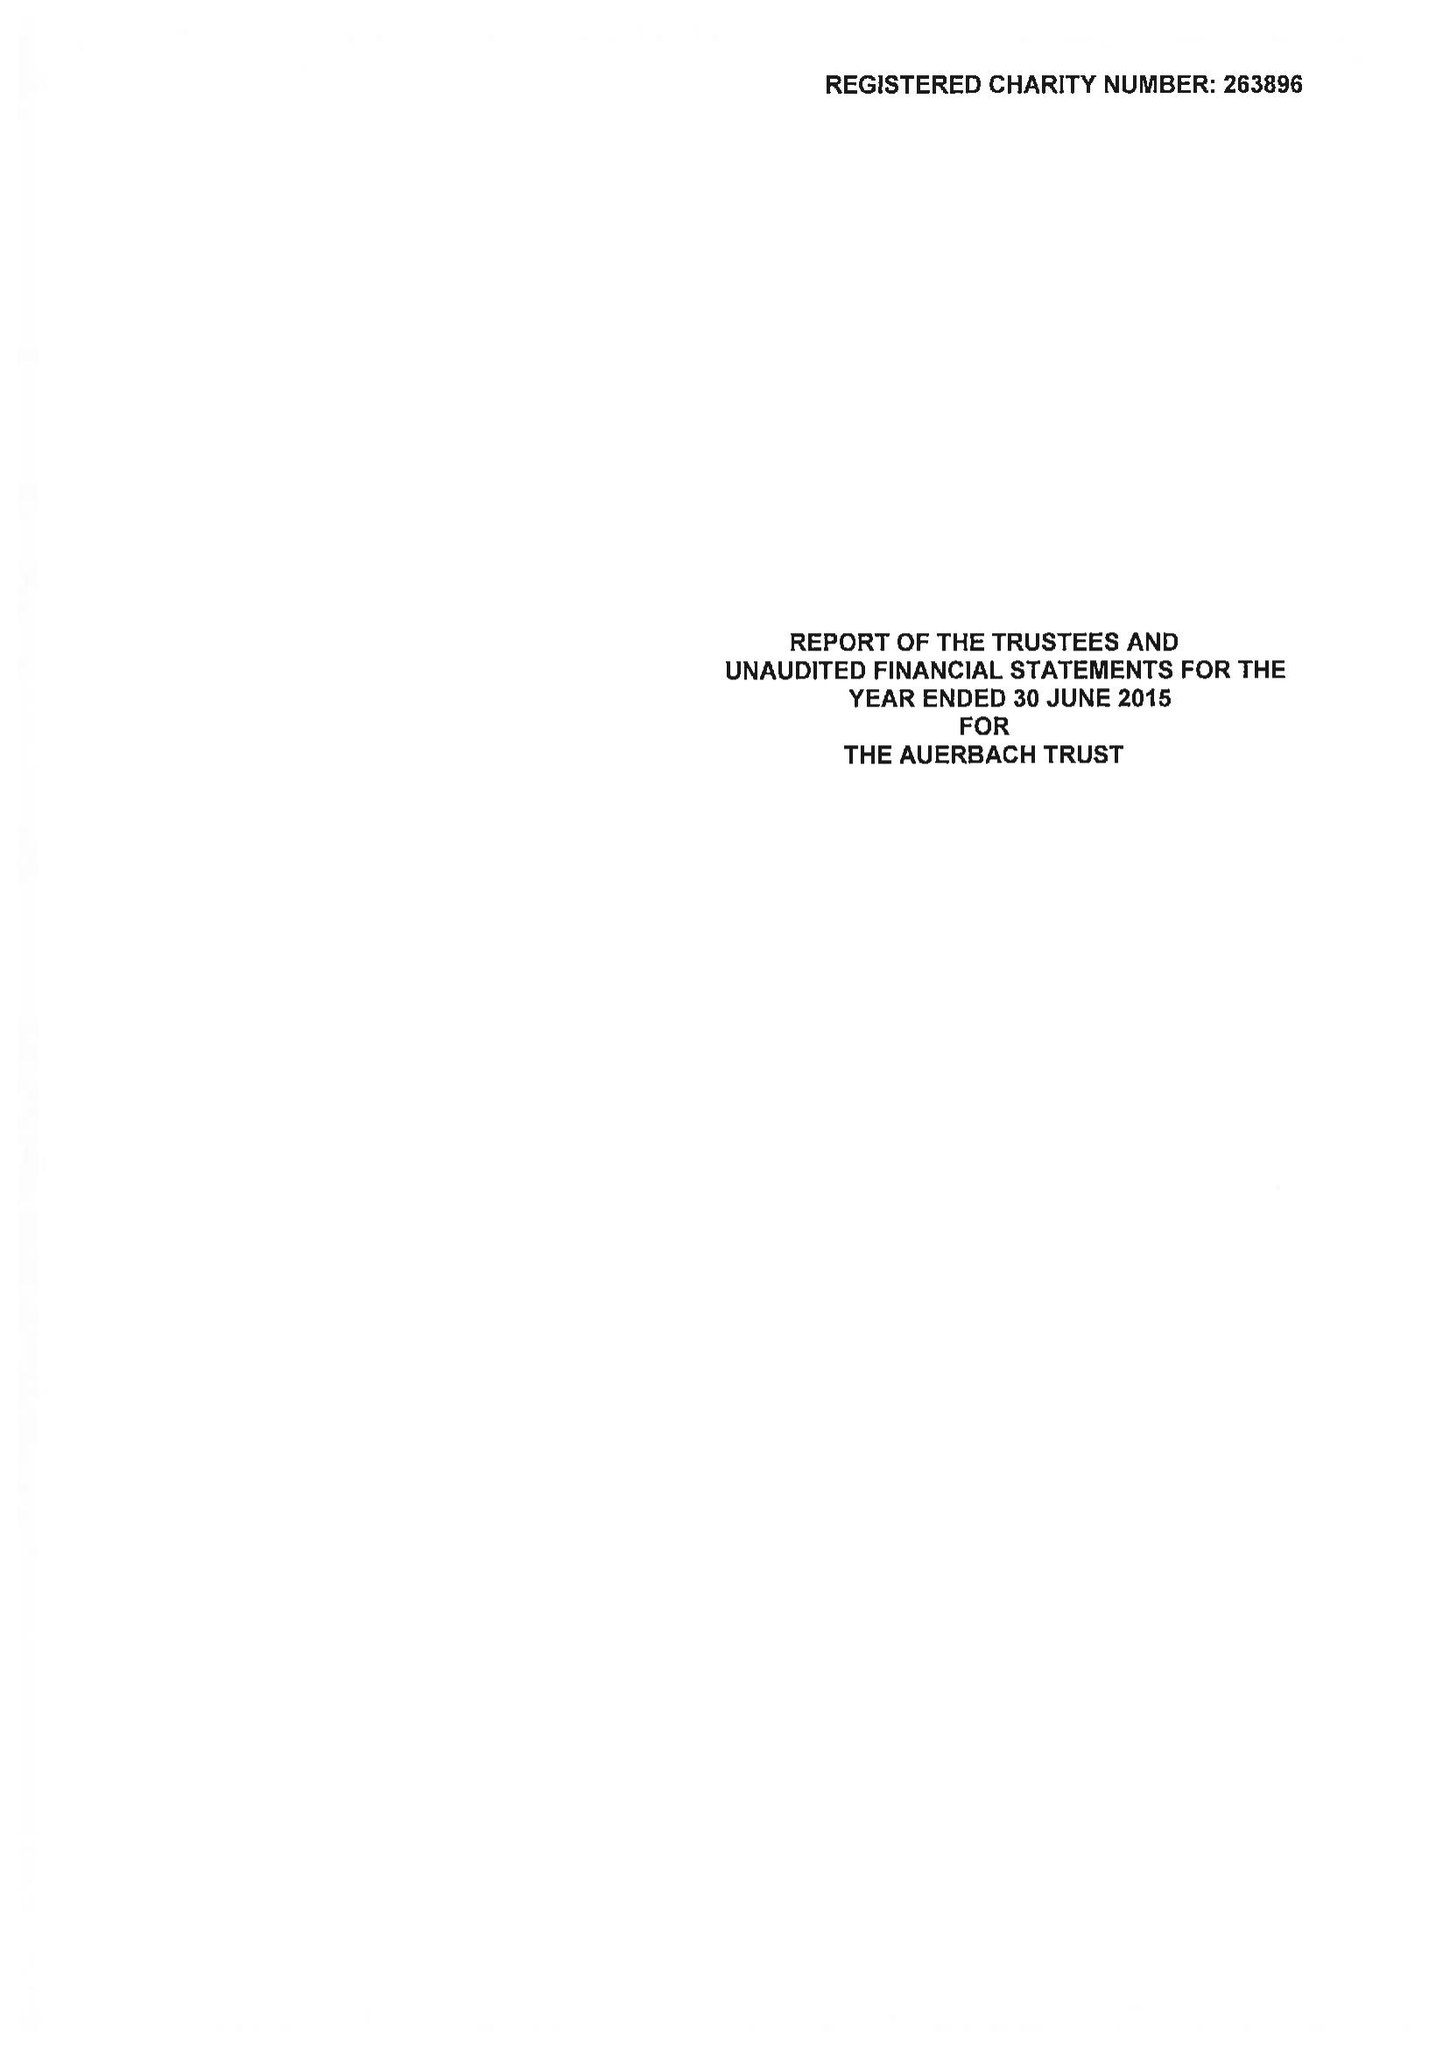What is the value for the report_date?
Answer the question using a single word or phrase. 2015-06-30 